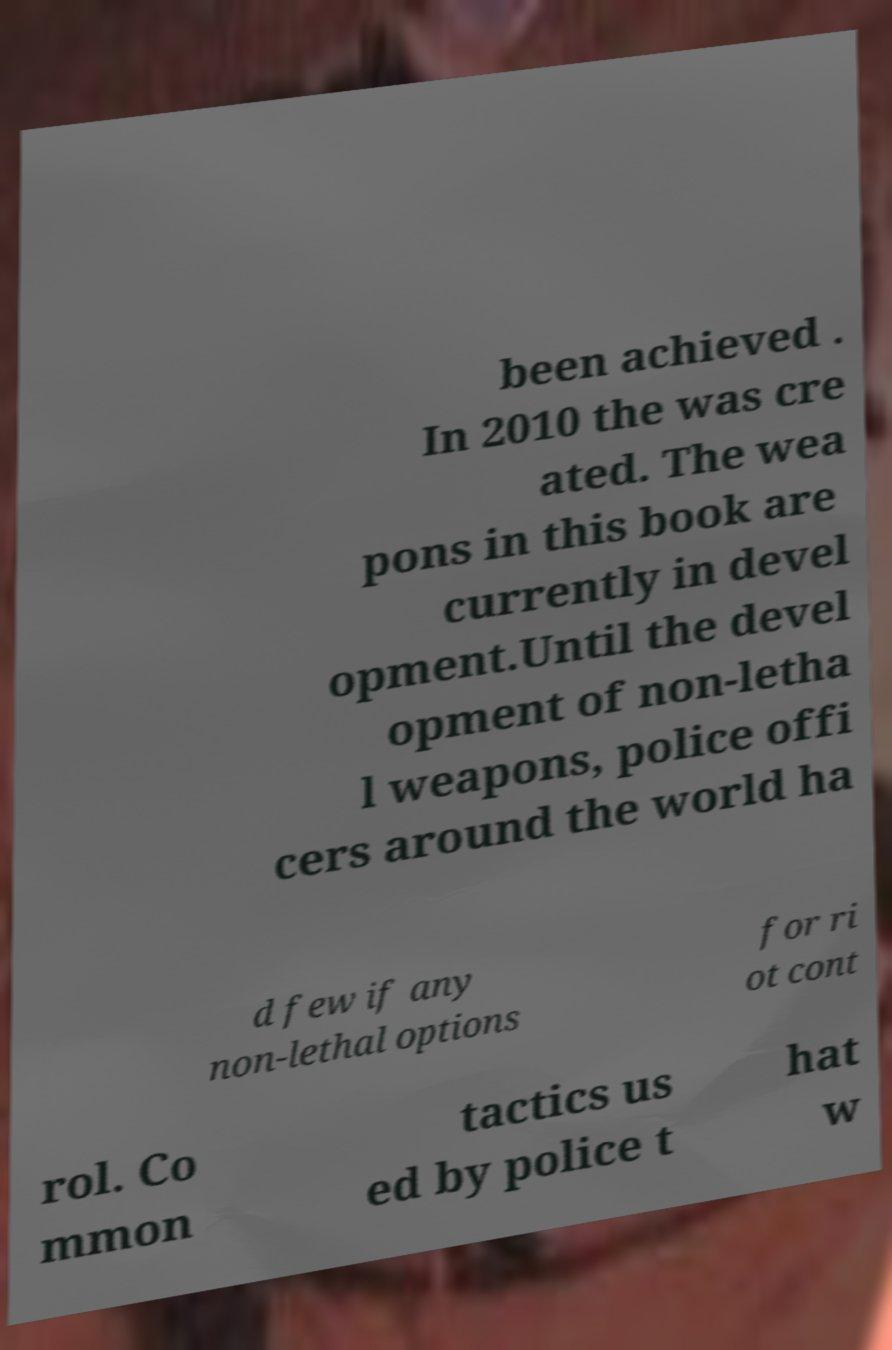Can you accurately transcribe the text from the provided image for me? been achieved . In 2010 the was cre ated. The wea pons in this book are currently in devel opment.Until the devel opment of non-letha l weapons, police offi cers around the world ha d few if any non-lethal options for ri ot cont rol. Co mmon tactics us ed by police t hat w 